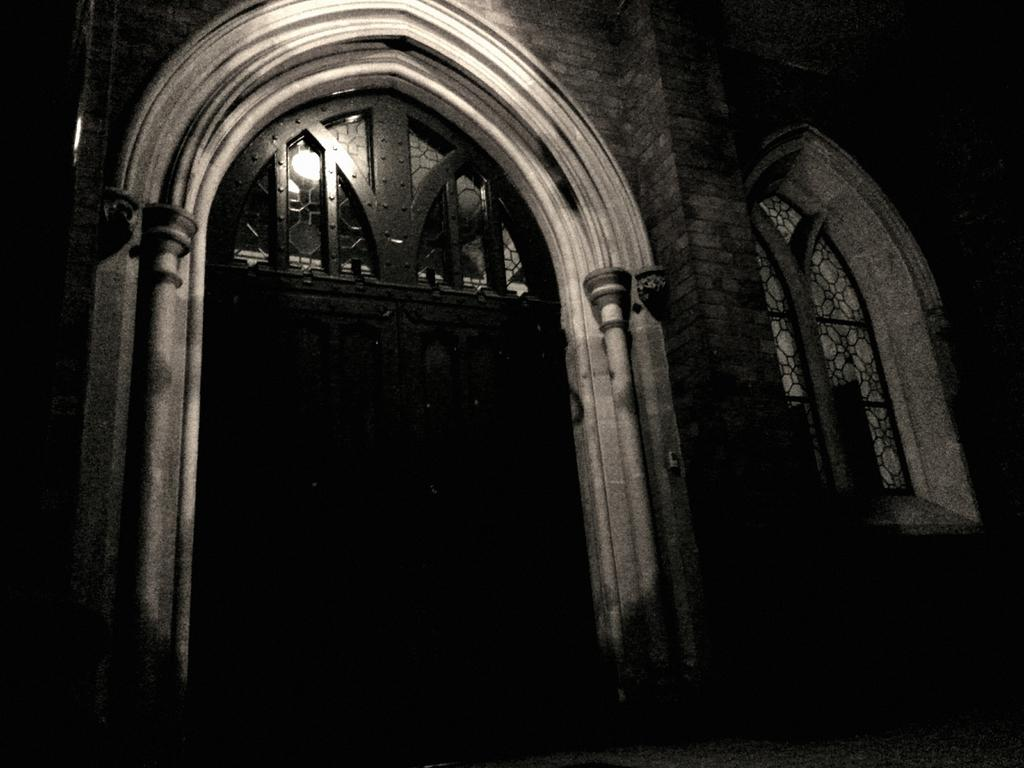What is the color scheme of the image? The image is black and white. What architectural features are present in the front of the image? There is a door and a window in the front of the image. Is there any lighting source visible in the image? Yes, there is a light over the top of the door and window. What grade does the door receive for its arm strength in the image? There is no mention of a grade or arm strength in the image, as it features a door and window with a light source. 